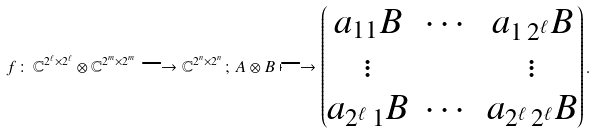Convert formula to latex. <formula><loc_0><loc_0><loc_500><loc_500>f \, \colon \, \mathbb { C } ^ { 2 ^ { \ell } \times 2 ^ { \ell } } \otimes \mathbb { C } ^ { 2 ^ { m } \times 2 ^ { m } } \longrightarrow \mathbb { C } ^ { 2 ^ { n } \times 2 ^ { n } } \, ; \, A \otimes B \longmapsto \begin{pmatrix} a _ { 1 1 } B & \cdots & a _ { 1 \, 2 ^ { \ell } } B \\ \vdots & & \vdots \\ a _ { 2 ^ { \ell } \, 1 } B & \cdots & a _ { 2 ^ { \ell } \, 2 ^ { \ell } } B \end{pmatrix} .</formula> 